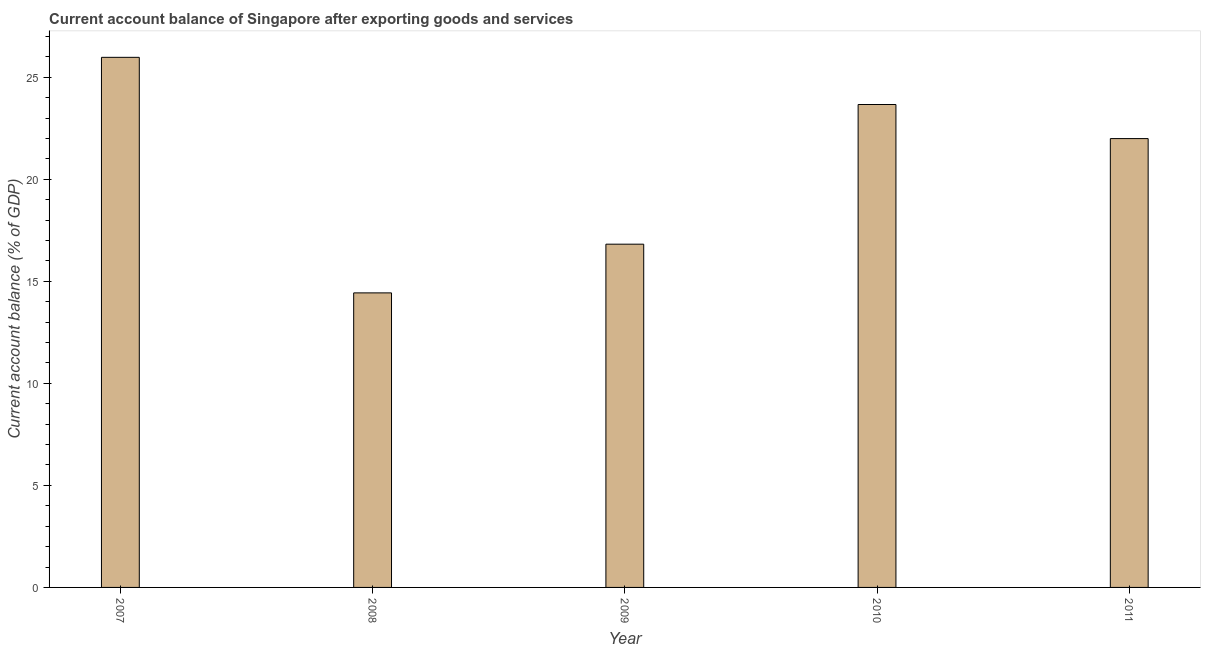What is the title of the graph?
Offer a terse response. Current account balance of Singapore after exporting goods and services. What is the label or title of the X-axis?
Give a very brief answer. Year. What is the label or title of the Y-axis?
Ensure brevity in your answer.  Current account balance (% of GDP). What is the current account balance in 2009?
Offer a terse response. 16.82. Across all years, what is the maximum current account balance?
Provide a short and direct response. 25.97. Across all years, what is the minimum current account balance?
Provide a short and direct response. 14.43. What is the sum of the current account balance?
Offer a terse response. 102.88. What is the difference between the current account balance in 2007 and 2009?
Offer a terse response. 9.16. What is the average current account balance per year?
Make the answer very short. 20.58. What is the median current account balance?
Provide a succinct answer. 21.99. In how many years, is the current account balance greater than 23 %?
Make the answer very short. 2. Do a majority of the years between 2008 and 2009 (inclusive) have current account balance greater than 22 %?
Make the answer very short. No. What is the ratio of the current account balance in 2007 to that in 2011?
Your answer should be compact. 1.18. What is the difference between the highest and the second highest current account balance?
Provide a succinct answer. 2.31. Is the sum of the current account balance in 2008 and 2011 greater than the maximum current account balance across all years?
Provide a short and direct response. Yes. What is the difference between the highest and the lowest current account balance?
Your answer should be very brief. 11.54. How many bars are there?
Make the answer very short. 5. What is the Current account balance (% of GDP) of 2007?
Keep it short and to the point. 25.97. What is the Current account balance (% of GDP) in 2008?
Offer a very short reply. 14.43. What is the Current account balance (% of GDP) in 2009?
Your answer should be very brief. 16.82. What is the Current account balance (% of GDP) of 2010?
Ensure brevity in your answer.  23.66. What is the Current account balance (% of GDP) of 2011?
Provide a short and direct response. 21.99. What is the difference between the Current account balance (% of GDP) in 2007 and 2008?
Make the answer very short. 11.54. What is the difference between the Current account balance (% of GDP) in 2007 and 2009?
Provide a short and direct response. 9.16. What is the difference between the Current account balance (% of GDP) in 2007 and 2010?
Provide a short and direct response. 2.31. What is the difference between the Current account balance (% of GDP) in 2007 and 2011?
Offer a terse response. 3.98. What is the difference between the Current account balance (% of GDP) in 2008 and 2009?
Your response must be concise. -2.39. What is the difference between the Current account balance (% of GDP) in 2008 and 2010?
Your answer should be very brief. -9.23. What is the difference between the Current account balance (% of GDP) in 2008 and 2011?
Your response must be concise. -7.56. What is the difference between the Current account balance (% of GDP) in 2009 and 2010?
Your answer should be compact. -6.84. What is the difference between the Current account balance (% of GDP) in 2009 and 2011?
Give a very brief answer. -5.17. What is the difference between the Current account balance (% of GDP) in 2010 and 2011?
Your response must be concise. 1.67. What is the ratio of the Current account balance (% of GDP) in 2007 to that in 2009?
Ensure brevity in your answer.  1.54. What is the ratio of the Current account balance (% of GDP) in 2007 to that in 2010?
Keep it short and to the point. 1.1. What is the ratio of the Current account balance (% of GDP) in 2007 to that in 2011?
Provide a succinct answer. 1.18. What is the ratio of the Current account balance (% of GDP) in 2008 to that in 2009?
Your answer should be compact. 0.86. What is the ratio of the Current account balance (% of GDP) in 2008 to that in 2010?
Ensure brevity in your answer.  0.61. What is the ratio of the Current account balance (% of GDP) in 2008 to that in 2011?
Your response must be concise. 0.66. What is the ratio of the Current account balance (% of GDP) in 2009 to that in 2010?
Provide a short and direct response. 0.71. What is the ratio of the Current account balance (% of GDP) in 2009 to that in 2011?
Keep it short and to the point. 0.77. What is the ratio of the Current account balance (% of GDP) in 2010 to that in 2011?
Make the answer very short. 1.08. 